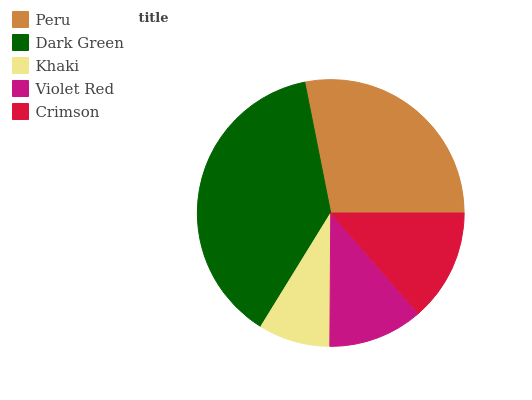Is Khaki the minimum?
Answer yes or no. Yes. Is Dark Green the maximum?
Answer yes or no. Yes. Is Dark Green the minimum?
Answer yes or no. No. Is Khaki the maximum?
Answer yes or no. No. Is Dark Green greater than Khaki?
Answer yes or no. Yes. Is Khaki less than Dark Green?
Answer yes or no. Yes. Is Khaki greater than Dark Green?
Answer yes or no. No. Is Dark Green less than Khaki?
Answer yes or no. No. Is Crimson the high median?
Answer yes or no. Yes. Is Crimson the low median?
Answer yes or no. Yes. Is Violet Red the high median?
Answer yes or no. No. Is Khaki the low median?
Answer yes or no. No. 